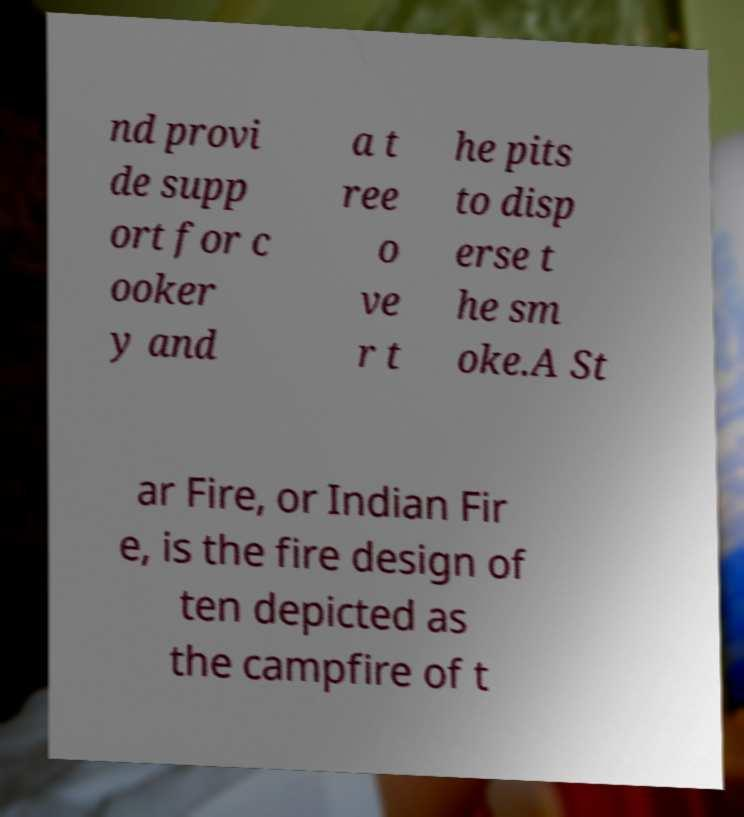I need the written content from this picture converted into text. Can you do that? nd provi de supp ort for c ooker y and a t ree o ve r t he pits to disp erse t he sm oke.A St ar Fire, or Indian Fir e, is the fire design of ten depicted as the campfire of t 